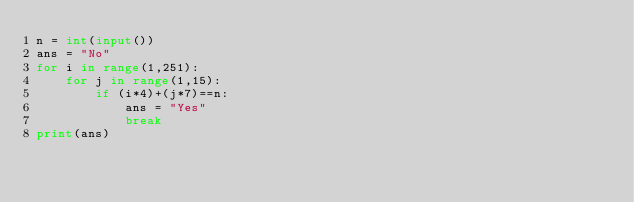Convert code to text. <code><loc_0><loc_0><loc_500><loc_500><_Python_>n = int(input())
ans = "No"
for i in range(1,251):
    for j in range(1,15):
        if (i*4)+(j*7)==n:
            ans = "Yes"
            break
print(ans)</code> 